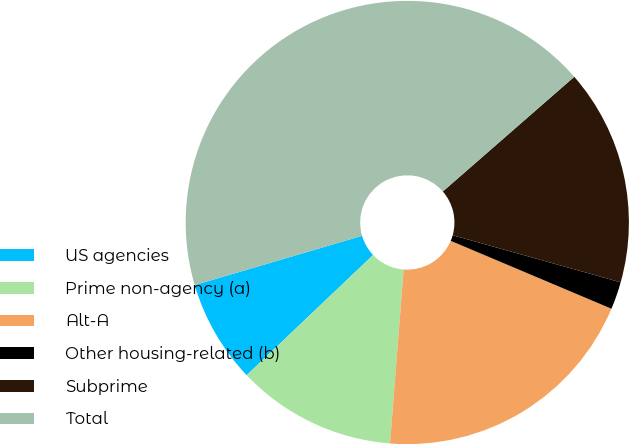<chart> <loc_0><loc_0><loc_500><loc_500><pie_chart><fcel>US agencies<fcel>Prime non-agency (a)<fcel>Alt-A<fcel>Other housing-related (b)<fcel>Subprime<fcel>Total<nl><fcel>7.54%<fcel>11.66%<fcel>19.88%<fcel>2.01%<fcel>15.77%<fcel>43.14%<nl></chart> 